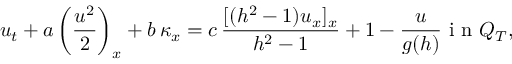<formula> <loc_0><loc_0><loc_500><loc_500>u _ { t } + a \left ( \frac { u ^ { 2 } } { 2 } \right ) _ { x } + b \, \kappa _ { x } = c \, \frac { [ ( h ^ { 2 } - 1 ) u _ { x } ] _ { x } } { h ^ { 2 } - 1 } + 1 - \frac { u } { g ( h ) } i n Q _ { T } ,</formula> 